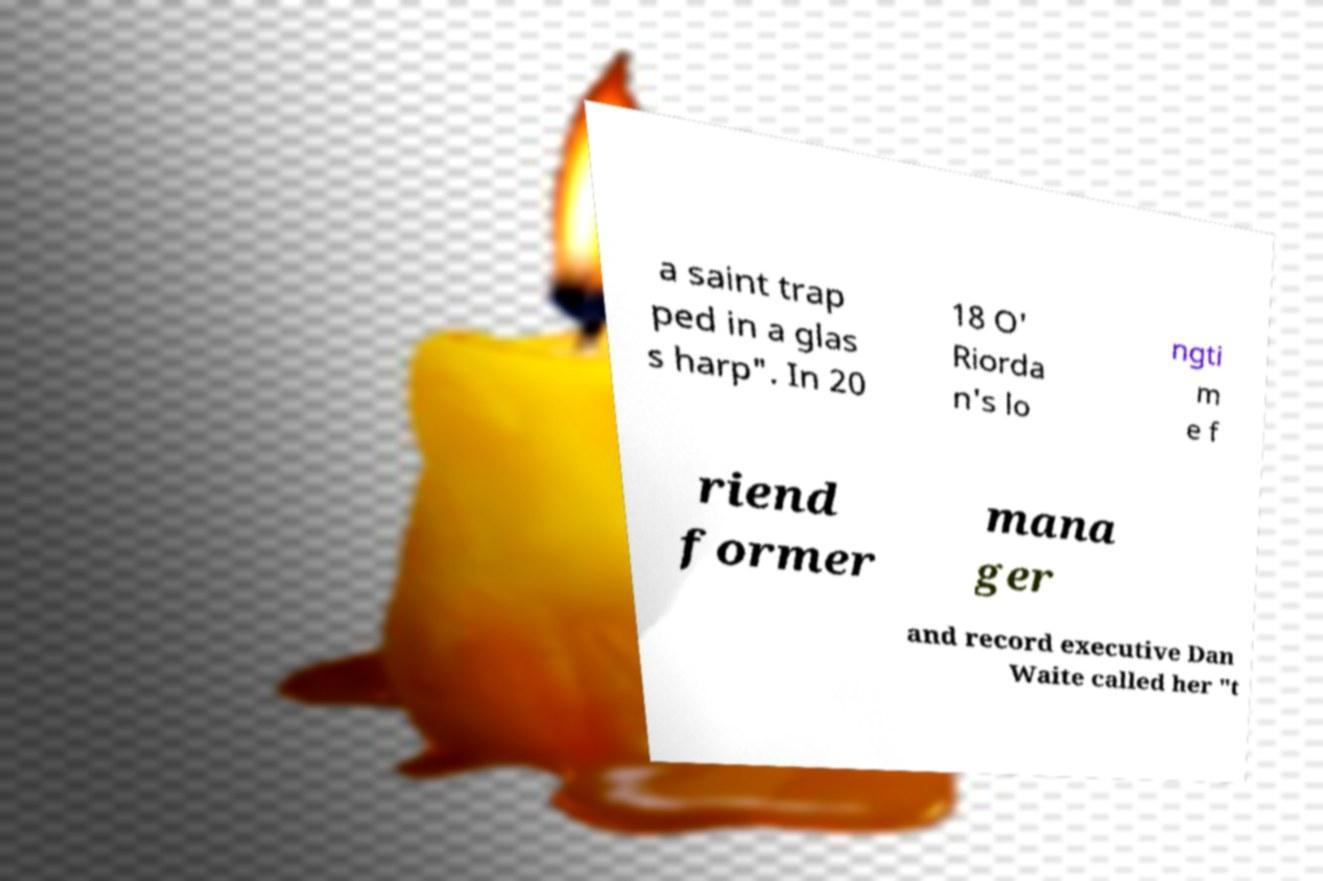What messages or text are displayed in this image? I need them in a readable, typed format. a saint trap ped in a glas s harp". In 20 18 O' Riorda n's lo ngti m e f riend former mana ger and record executive Dan Waite called her "t 